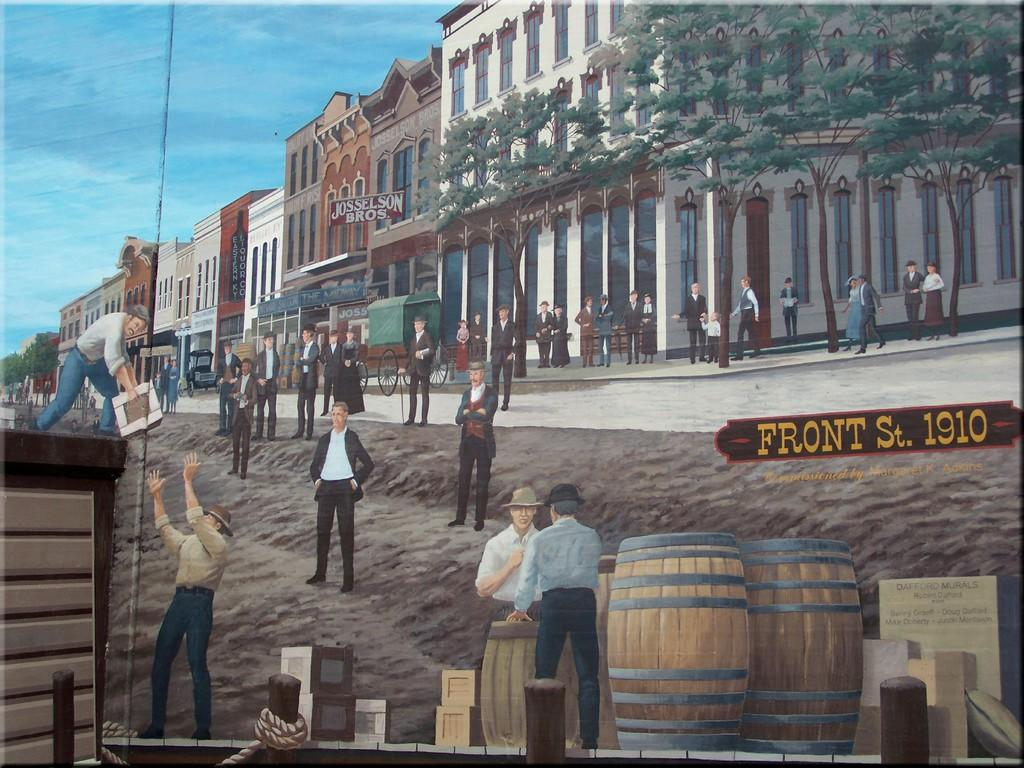What is present in the image? There are persons standing in the image. What can be seen in the background of the image? There are buildings and trees in the background of the image. What are the hobbies of the trees in the image? Trees do not have hobbies, as they are inanimate objects. How is the distribution of the buildings in the image? The provided facts do not give information about the distribution of the buildings in the image. 